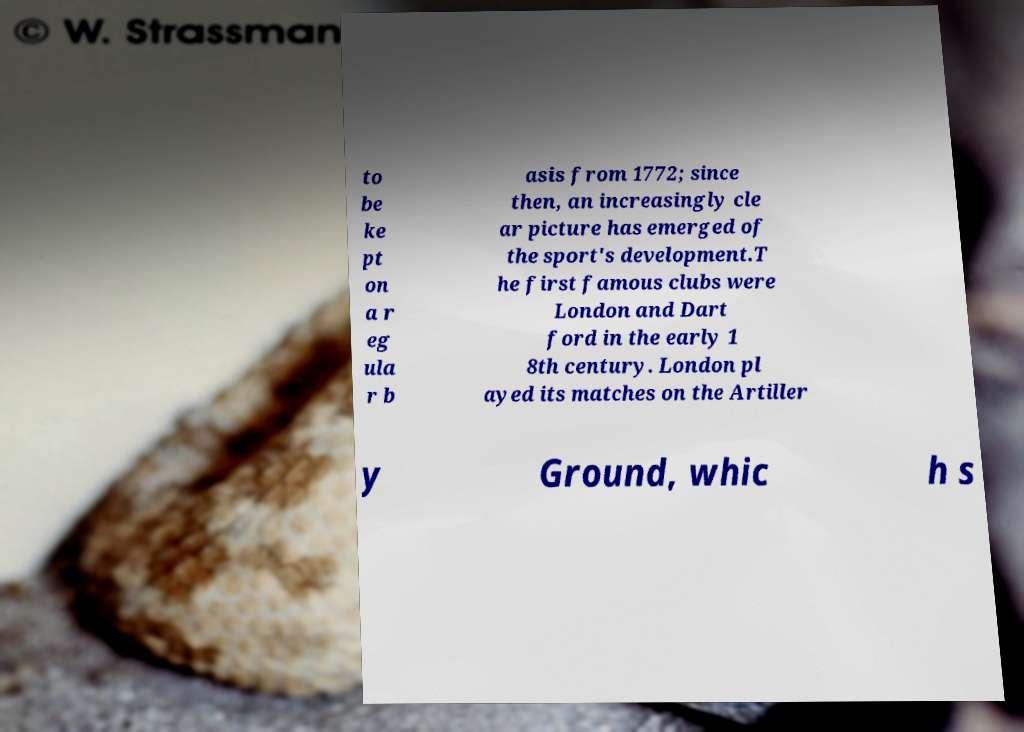Please identify and transcribe the text found in this image. to be ke pt on a r eg ula r b asis from 1772; since then, an increasingly cle ar picture has emerged of the sport's development.T he first famous clubs were London and Dart ford in the early 1 8th century. London pl ayed its matches on the Artiller y Ground, whic h s 